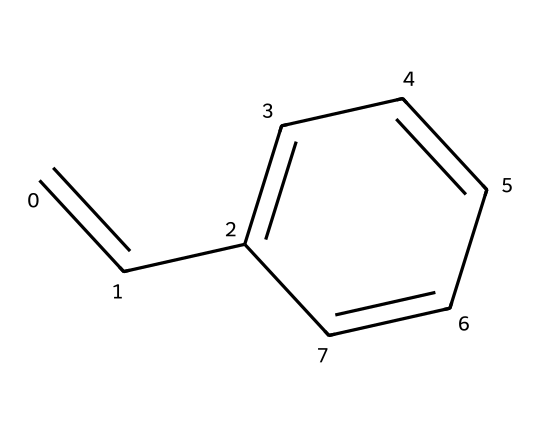What is the molecular formula of styrene? The structure has a total of 8 carbon atoms and 8 hydrogen atoms, which gives the molecular formula C8H8.
Answer: C8H8 How many double bonds are present in the structure? Upon examining the structure, there is one double bond between two carbon atoms (the vinyl group) and another double bond within the aromatic ring, leading to a total of two.
Answer: 2 What type of hydrocarbon is styrene classified as? Styrene contains a vinyl group and an aromatic ring; thus, it can be classified as an alkenyl aromatic hydrocarbon.
Answer: alkenyl aromatic Which part of styrene's structure is responsible for its reactivity? The double bond in the vinyl group is responsible for the reactivity, allowing styrene to polymerize and readily react with other compounds.
Answer: double bond What is the total number of hydrogen atoms attached to the central carbon atoms in styrene? The structure depicts that each of the central carbon atoms in the vinyl group is bonded to one hydrogen atom, together contributing a total of two hydrogen atoms.
Answer: 2 What feature of styrene’s structure allows it to be a monomer for polymers? The presence of the double bond in styrene allows it to undergo addition reactions, making it suitable for polymerization processes.
Answer: double bond 